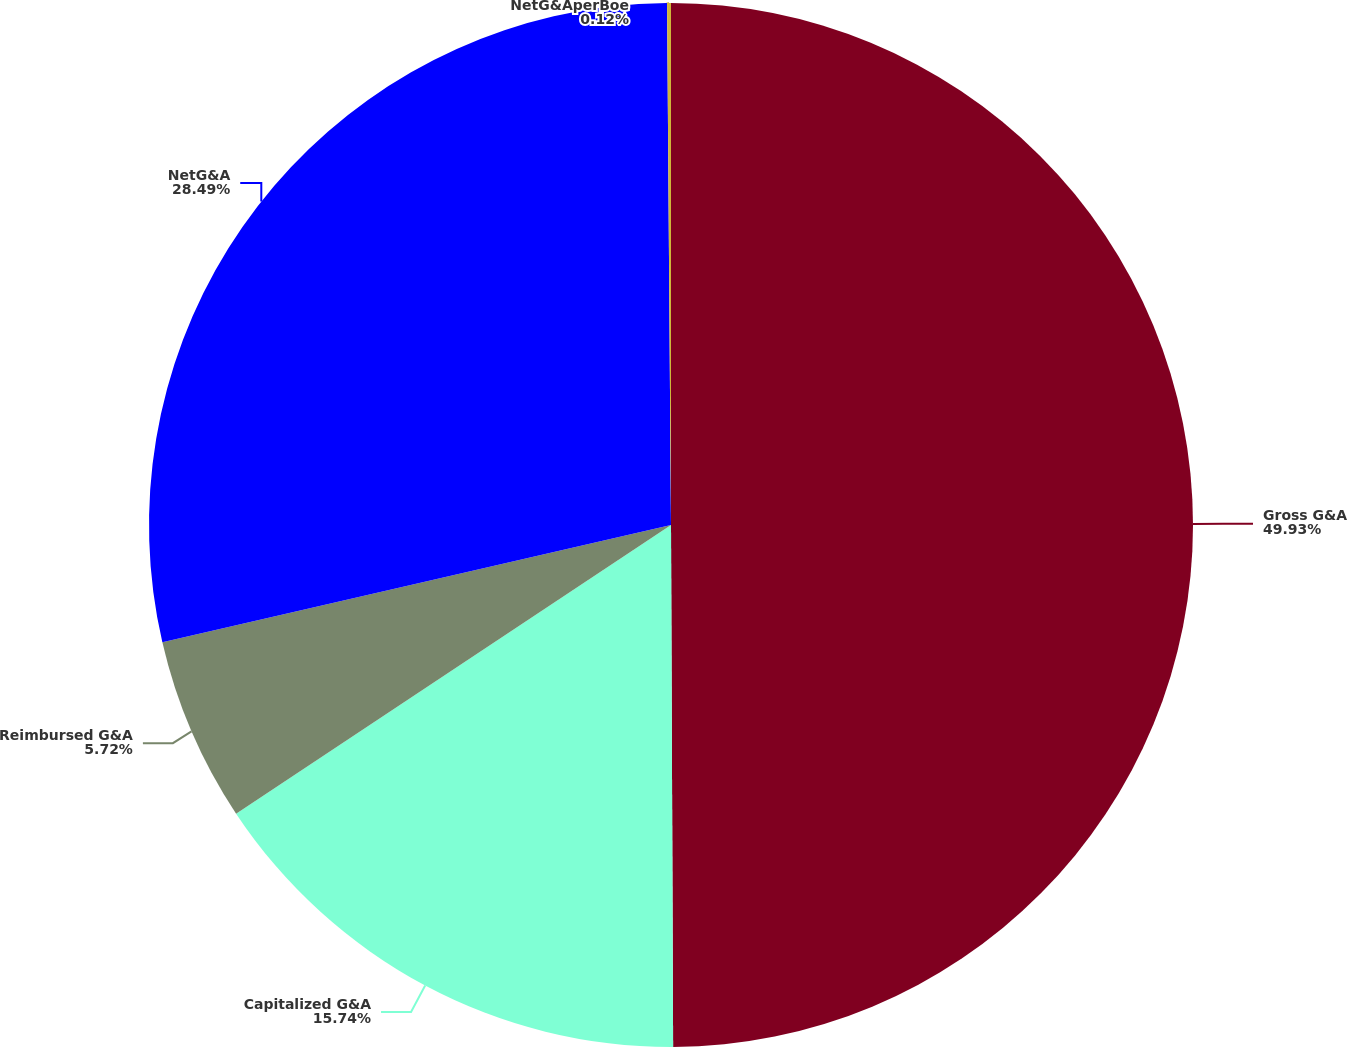<chart> <loc_0><loc_0><loc_500><loc_500><pie_chart><fcel>Gross G&A<fcel>Capitalized G&A<fcel>Reimbursed G&A<fcel>NetG&A<fcel>NetG&AperBoe<nl><fcel>49.94%<fcel>15.74%<fcel>5.72%<fcel>28.49%<fcel>0.12%<nl></chart> 